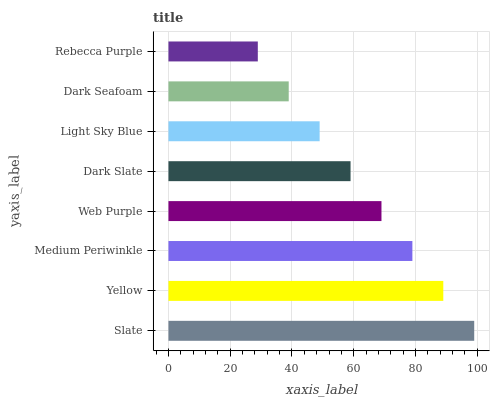Is Rebecca Purple the minimum?
Answer yes or no. Yes. Is Slate the maximum?
Answer yes or no. Yes. Is Yellow the minimum?
Answer yes or no. No. Is Yellow the maximum?
Answer yes or no. No. Is Slate greater than Yellow?
Answer yes or no. Yes. Is Yellow less than Slate?
Answer yes or no. Yes. Is Yellow greater than Slate?
Answer yes or no. No. Is Slate less than Yellow?
Answer yes or no. No. Is Web Purple the high median?
Answer yes or no. Yes. Is Dark Slate the low median?
Answer yes or no. Yes. Is Medium Periwinkle the high median?
Answer yes or no. No. Is Slate the low median?
Answer yes or no. No. 